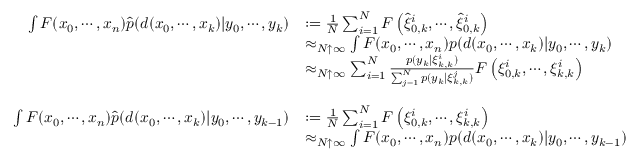Convert formula to latex. <formula><loc_0><loc_0><loc_500><loc_500>{ \begin{array} { r l } { \int F ( x _ { 0 } , \cdots , x _ { n } ) { \widehat { p } } ( d ( x _ { 0 } , \cdots , x _ { k } ) | y _ { 0 } , \cdots , y _ { k } ) } & { \colon = { \frac { 1 } { N } } \sum _ { i = 1 } ^ { N } F \left ( { \widehat { \xi } } _ { 0 , k } ^ { i } , \cdots , { \widehat { \xi } } _ { 0 , k } ^ { i } \right ) } \\ & { \approx _ { N \uparrow \infty } \int F ( x _ { 0 } , \cdots , x _ { n } ) p ( d ( x _ { 0 } , \cdots , x _ { k } ) | y _ { 0 } , \cdots , y _ { k } ) } \\ & { \approx _ { N \uparrow \infty } \sum _ { i = 1 } ^ { N } { \frac { p ( y _ { k } | \xi _ { k , k } ^ { i } ) } { \sum _ { j = 1 } ^ { N } p ( y _ { k } | \xi _ { k , k } ^ { j } ) } } F \left ( \xi _ { 0 , k } ^ { i } , \cdots , \xi _ { k , k } ^ { i } \right ) } \\ & { \ } \\ { \int F ( x _ { 0 } , \cdots , x _ { n } ) { \widehat { p } } ( d ( x _ { 0 } , \cdots , x _ { k } ) | y _ { 0 } , \cdots , y _ { k - 1 } ) } & { \colon = { \frac { 1 } { N } } \sum _ { i = 1 } ^ { N } F \left ( \xi _ { 0 , k } ^ { i } , \cdots , \xi _ { k , k } ^ { i } \right ) } \\ & { \approx _ { N \uparrow \infty } \int F ( x _ { 0 } , \cdots , x _ { n } ) p ( d ( x _ { 0 } , \cdots , x _ { k } ) | y _ { 0 } , \cdots , y _ { k - 1 } ) } \end{array} }</formula> 